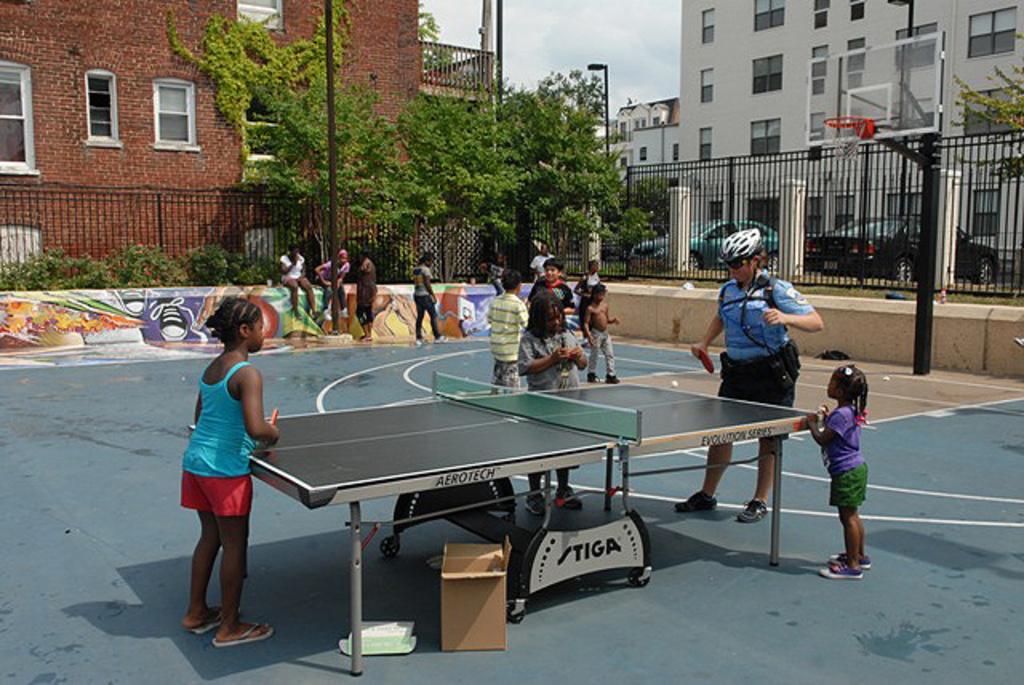Can you describe this image briefly? This picture describes about group of people, two are playing table tennis, in the background we can find couple of buildings, cars, poles and trees. 